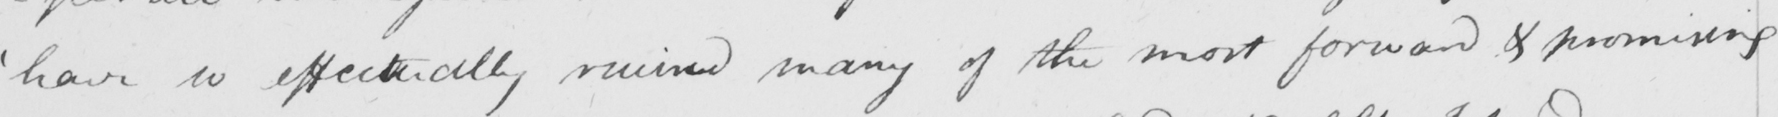Transcribe the text shown in this historical manuscript line. ' have so effectually ruined many of the most forward & promising 